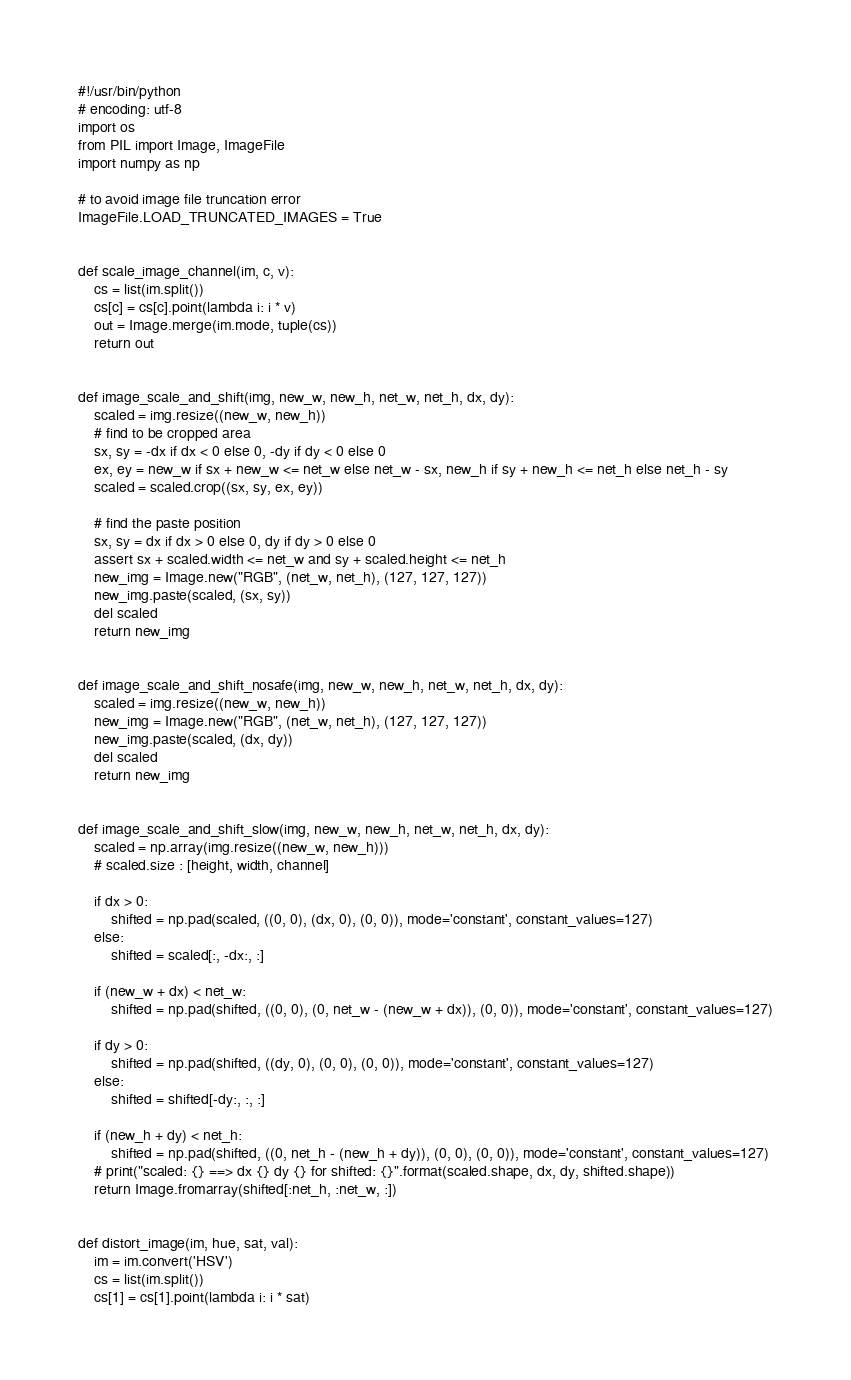<code> <loc_0><loc_0><loc_500><loc_500><_Python_>#!/usr/bin/python
# encoding: utf-8
import os
from PIL import Image, ImageFile
import numpy as np

# to avoid image file truncation error
ImageFile.LOAD_TRUNCATED_IMAGES = True


def scale_image_channel(im, c, v):
    cs = list(im.split())
    cs[c] = cs[c].point(lambda i: i * v)
    out = Image.merge(im.mode, tuple(cs))
    return out


def image_scale_and_shift(img, new_w, new_h, net_w, net_h, dx, dy):
    scaled = img.resize((new_w, new_h))
    # find to be cropped area
    sx, sy = -dx if dx < 0 else 0, -dy if dy < 0 else 0
    ex, ey = new_w if sx + new_w <= net_w else net_w - sx, new_h if sy + new_h <= net_h else net_h - sy
    scaled = scaled.crop((sx, sy, ex, ey))

    # find the paste position
    sx, sy = dx if dx > 0 else 0, dy if dy > 0 else 0
    assert sx + scaled.width <= net_w and sy + scaled.height <= net_h
    new_img = Image.new("RGB", (net_w, net_h), (127, 127, 127))
    new_img.paste(scaled, (sx, sy))
    del scaled
    return new_img


def image_scale_and_shift_nosafe(img, new_w, new_h, net_w, net_h, dx, dy):
    scaled = img.resize((new_w, new_h))
    new_img = Image.new("RGB", (net_w, net_h), (127, 127, 127))
    new_img.paste(scaled, (dx, dy))
    del scaled
    return new_img


def image_scale_and_shift_slow(img, new_w, new_h, net_w, net_h, dx, dy):
    scaled = np.array(img.resize((new_w, new_h)))
    # scaled.size : [height, width, channel]

    if dx > 0:
        shifted = np.pad(scaled, ((0, 0), (dx, 0), (0, 0)), mode='constant', constant_values=127)
    else:
        shifted = scaled[:, -dx:, :]

    if (new_w + dx) < net_w:
        shifted = np.pad(shifted, ((0, 0), (0, net_w - (new_w + dx)), (0, 0)), mode='constant', constant_values=127)

    if dy > 0:
        shifted = np.pad(shifted, ((dy, 0), (0, 0), (0, 0)), mode='constant', constant_values=127)
    else:
        shifted = shifted[-dy:, :, :]

    if (new_h + dy) < net_h:
        shifted = np.pad(shifted, ((0, net_h - (new_h + dy)), (0, 0), (0, 0)), mode='constant', constant_values=127)
    # print("scaled: {} ==> dx {} dy {} for shifted: {}".format(scaled.shape, dx, dy, shifted.shape))
    return Image.fromarray(shifted[:net_h, :net_w, :])


def distort_image(im, hue, sat, val):
    im = im.convert('HSV')
    cs = list(im.split())
    cs[1] = cs[1].point(lambda i: i * sat)</code> 